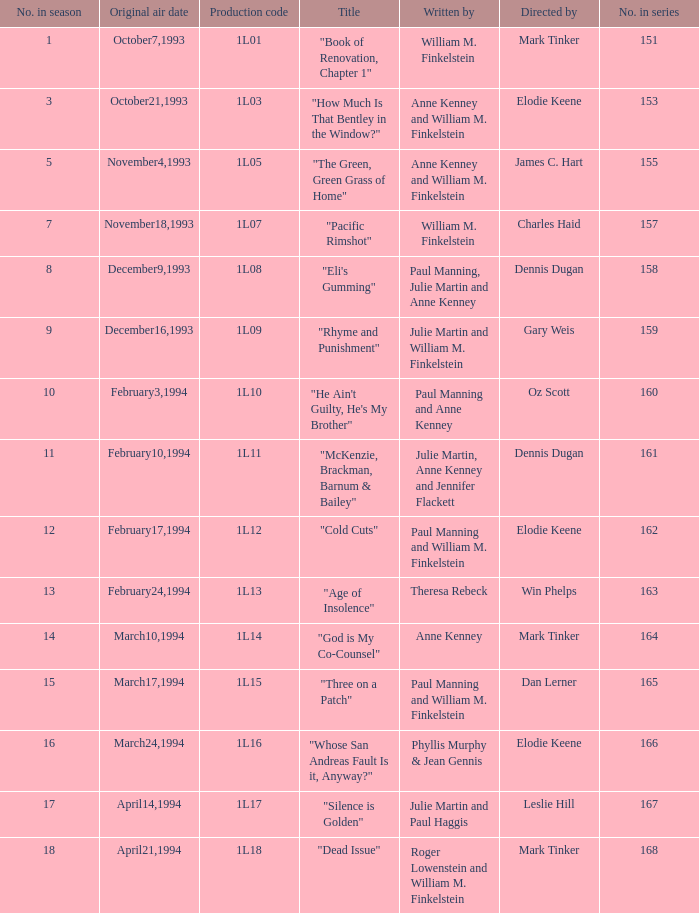Name the production code for theresa rebeck 1L13. 